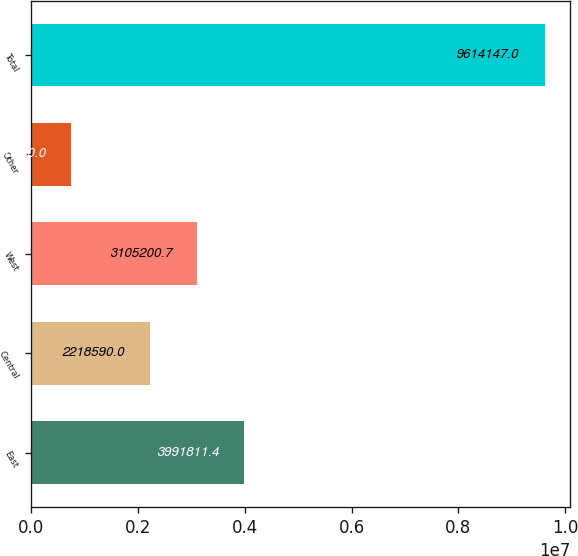<chart> <loc_0><loc_0><loc_500><loc_500><bar_chart><fcel>East<fcel>Central<fcel>West<fcel>Other<fcel>Total<nl><fcel>3.99181e+06<fcel>2.21859e+06<fcel>3.1052e+06<fcel>748040<fcel>9.61415e+06<nl></chart> 